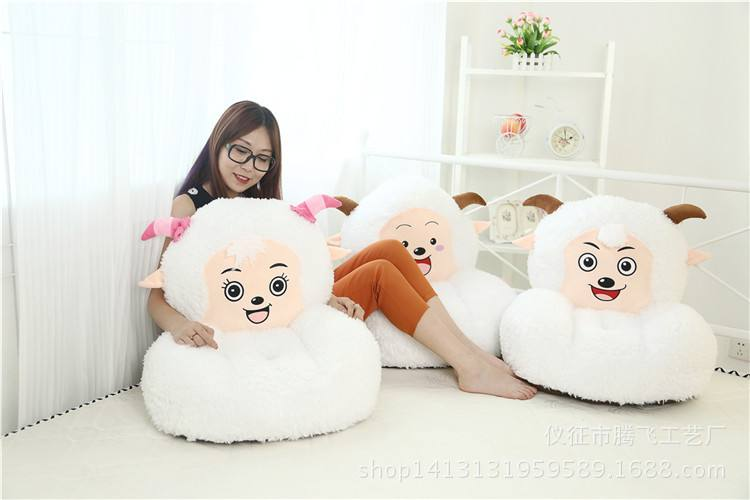Can you tell what the function of this room could be based on its setup? Based on the setup, this room appears to function as a casual sitting or play area, possibly aimed at children or as a creative space, given the playful design of the sofas and the uncluttered arrangement emphasizing spaciousness and comfort. 